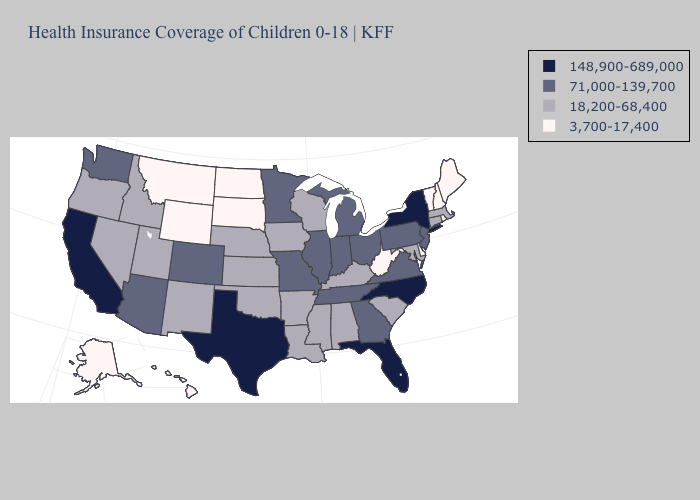Does Idaho have the lowest value in the West?
Keep it brief. No. Is the legend a continuous bar?
Keep it brief. No. What is the lowest value in the MidWest?
Give a very brief answer. 3,700-17,400. Does Minnesota have the lowest value in the USA?
Write a very short answer. No. What is the highest value in the South ?
Answer briefly. 148,900-689,000. What is the value of Florida?
Be succinct. 148,900-689,000. What is the lowest value in the West?
Concise answer only. 3,700-17,400. Name the states that have a value in the range 71,000-139,700?
Concise answer only. Arizona, Colorado, Georgia, Illinois, Indiana, Michigan, Minnesota, Missouri, New Jersey, Ohio, Pennsylvania, Tennessee, Virginia, Washington. What is the value of Mississippi?
Be succinct. 18,200-68,400. Name the states that have a value in the range 18,200-68,400?
Keep it brief. Alabama, Arkansas, Connecticut, Idaho, Iowa, Kansas, Kentucky, Louisiana, Maryland, Massachusetts, Mississippi, Nebraska, Nevada, New Mexico, Oklahoma, Oregon, South Carolina, Utah, Wisconsin. Does Nevada have the lowest value in the West?
Answer briefly. No. Which states hav the highest value in the Northeast?
Write a very short answer. New York. What is the value of Arkansas?
Give a very brief answer. 18,200-68,400. Name the states that have a value in the range 18,200-68,400?
Short answer required. Alabama, Arkansas, Connecticut, Idaho, Iowa, Kansas, Kentucky, Louisiana, Maryland, Massachusetts, Mississippi, Nebraska, Nevada, New Mexico, Oklahoma, Oregon, South Carolina, Utah, Wisconsin. Does Arizona have a lower value than New York?
Answer briefly. Yes. 